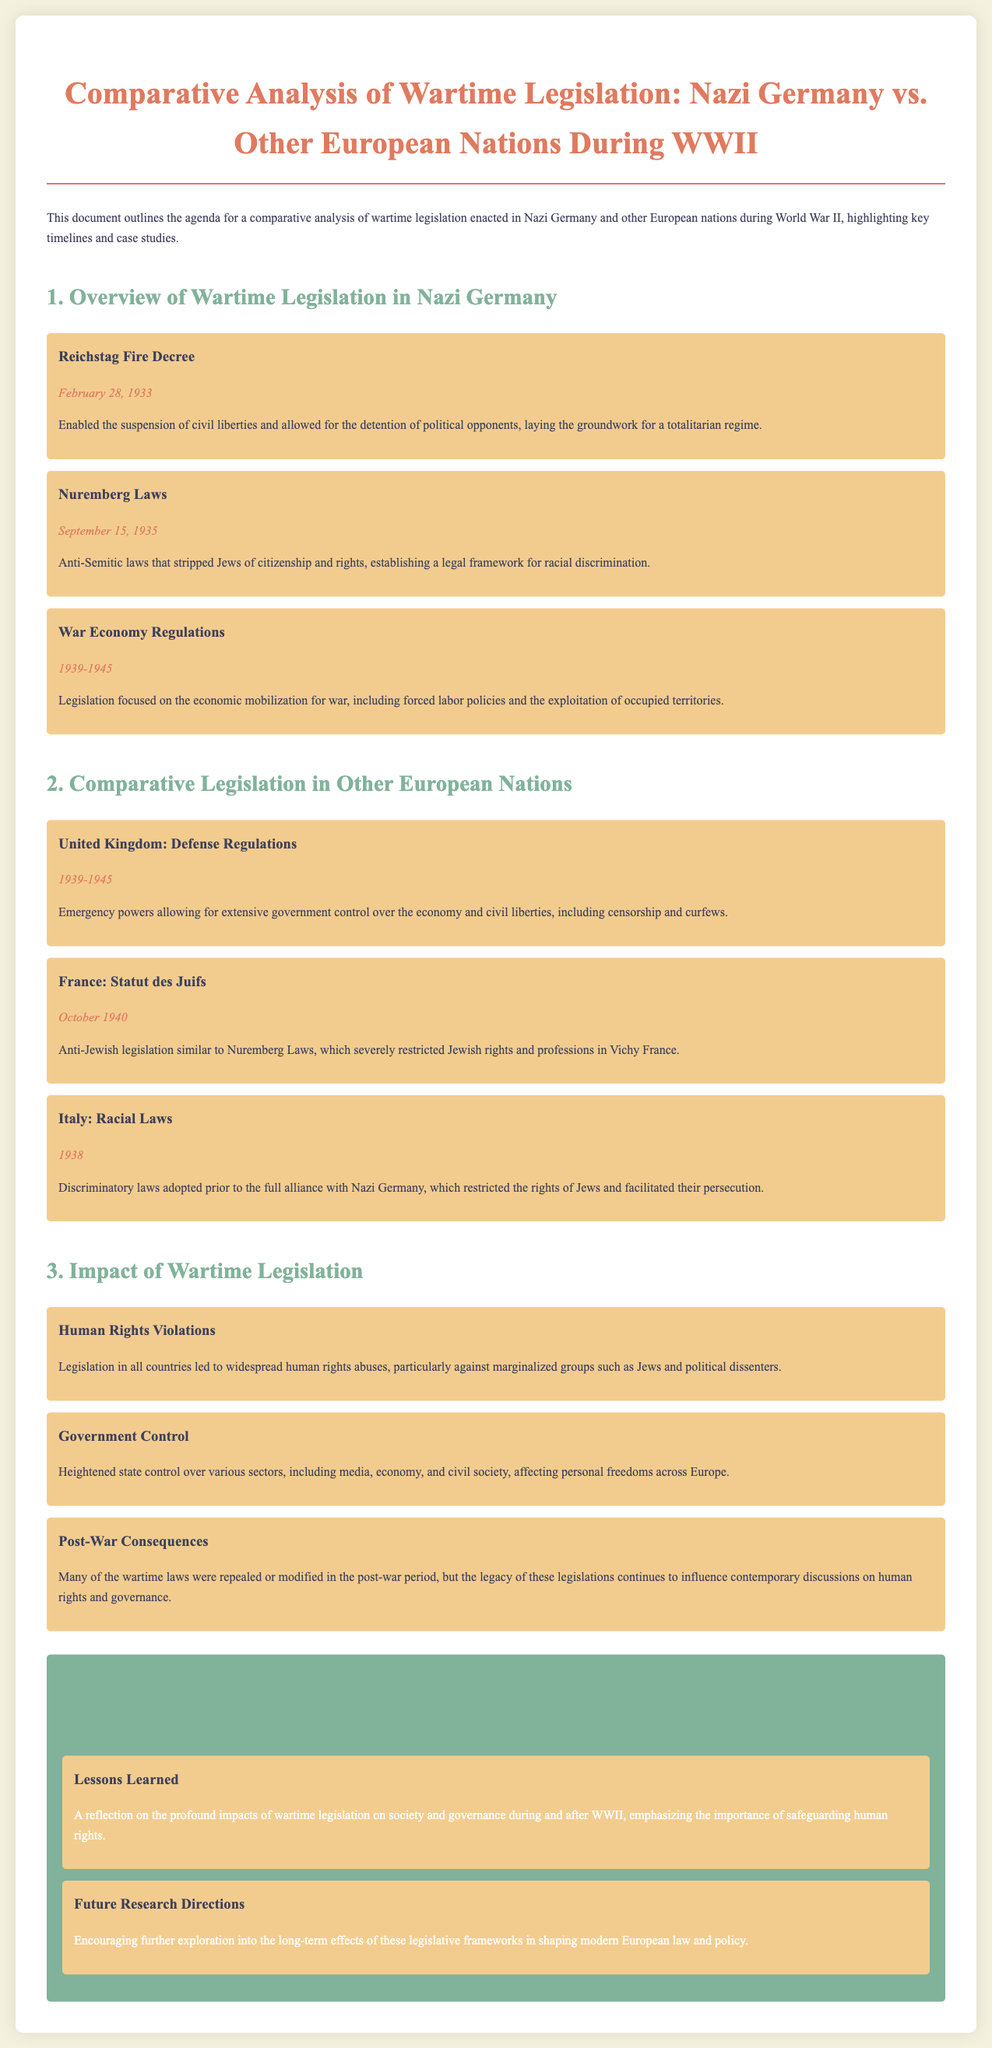what legislation enabled the suspension of civil liberties in Nazi Germany? The Reichstag Fire Decree is mentioned as enabling the suspension of civil liberties.
Answer: Reichstag Fire Decree when were the Nuremberg Laws enacted? The date provided for the Nuremberg Laws is September 15, 1935.
Answer: September 15, 1935 which country enacted the Statut des Juifs? The document states that France enacted the Statut des Juifs.
Answer: France what was the focus of War Economy Regulations in Nazi Germany? The document describes the focus as economic mobilization for war, including forced labor policies.
Answer: Economic mobilization for war how did wartime legislation impact human rights? The document notes that legislation led to widespread human rights abuses, particularly against marginalized groups.
Answer: Widespread human rights abuses what year was the United Kingdom's Defense Regulations in effect? The Defense Regulations were in effect from 1939 to 1945.
Answer: 1939-1945 what was a common consequence of wartime legislation across Europe? The document indicates that heightened state control over various sectors was a common consequence.
Answer: Heightened state control what reflection is offered regarding wartime legislation's impact? The document reflects on the profound impacts of wartime legislation on society and governance during and after WWII.
Answer: Profound impacts on society and governance what do the concluding remarks encourage? The concluding remarks mention encouraging further exploration into the long-term effects of legislative frameworks.
Answer: Further exploration into long-term effects 